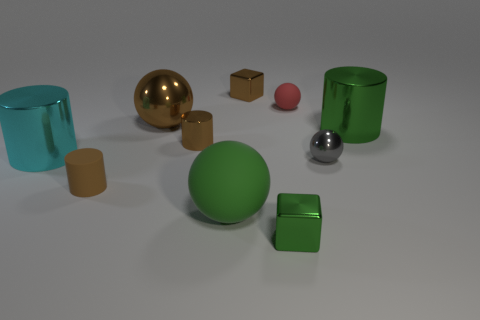Subtract all blue spheres. Subtract all purple cubes. How many spheres are left? 4 Subtract all cylinders. How many objects are left? 6 Add 5 brown rubber cylinders. How many brown rubber cylinders are left? 6 Add 5 tiny metal cubes. How many tiny metal cubes exist? 7 Subtract 0 yellow balls. How many objects are left? 10 Subtract all brown rubber cylinders. Subtract all tiny metallic cylinders. How many objects are left? 8 